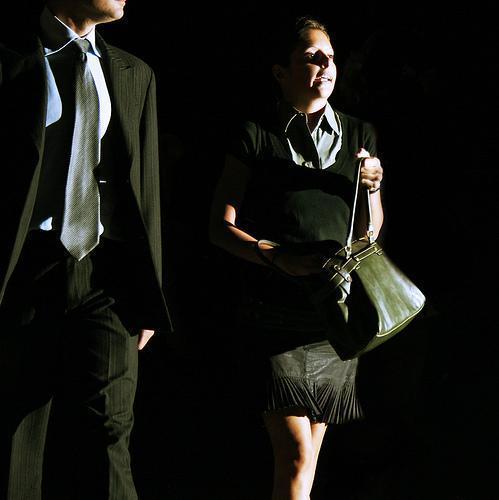How many people can be seen?
Give a very brief answer. 2. 